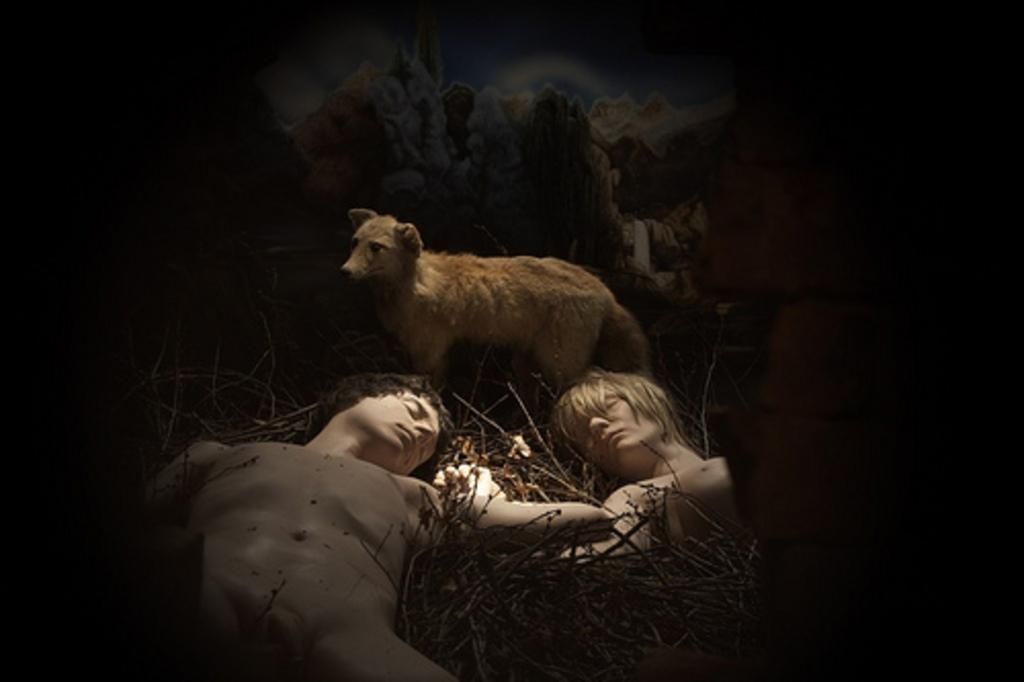What are the two people in the image doing? The two people are lying on the floor in the image. What else can be seen on the floor in the image? There are twigs on the floor in the image. What animal is present in the image? There is a wolf standing in the image. How would you describe the lighting in the image? The background of the image is dark. What type of cup is being used by the wolf in the image? There is no cup present in the image, and the wolf is not using any object. 